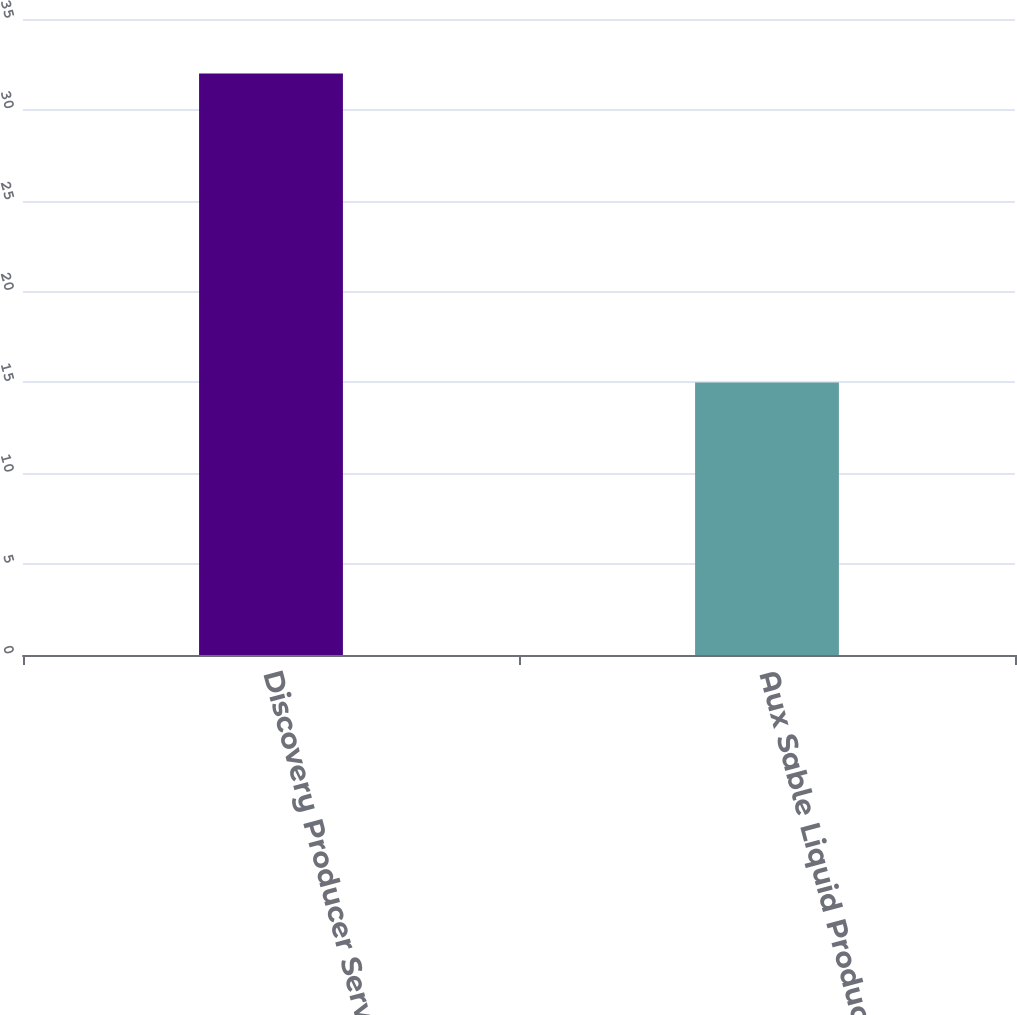<chart> <loc_0><loc_0><loc_500><loc_500><bar_chart><fcel>Discovery Producer Services<fcel>Aux Sable Liquid Products LP<nl><fcel>32<fcel>15<nl></chart> 